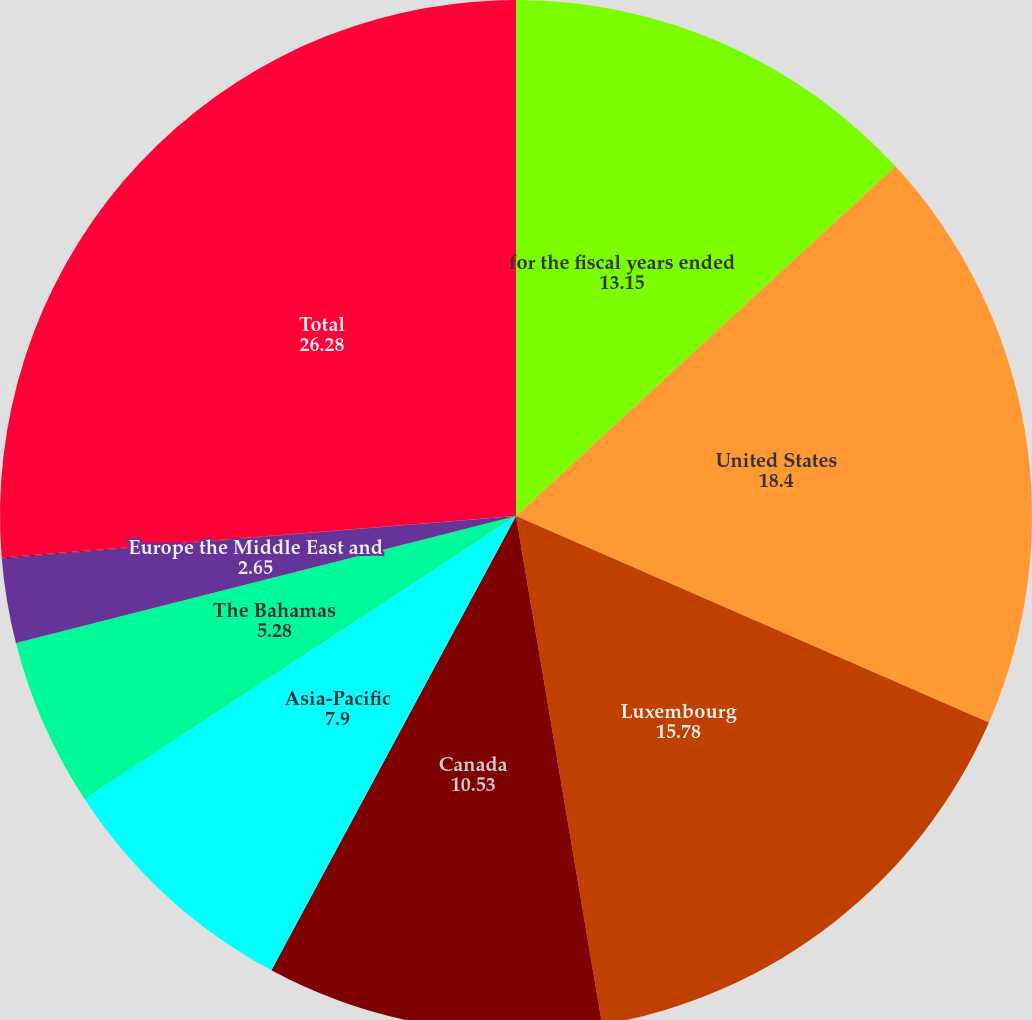Convert chart to OTSL. <chart><loc_0><loc_0><loc_500><loc_500><pie_chart><fcel>for the fiscal years ended<fcel>United States<fcel>Luxembourg<fcel>Canada<fcel>Asia-Pacific<fcel>The Bahamas<fcel>Europe the Middle East and<fcel>Latin America<fcel>Total<nl><fcel>13.15%<fcel>18.4%<fcel>15.78%<fcel>10.53%<fcel>7.9%<fcel>5.28%<fcel>2.65%<fcel>0.03%<fcel>26.28%<nl></chart> 